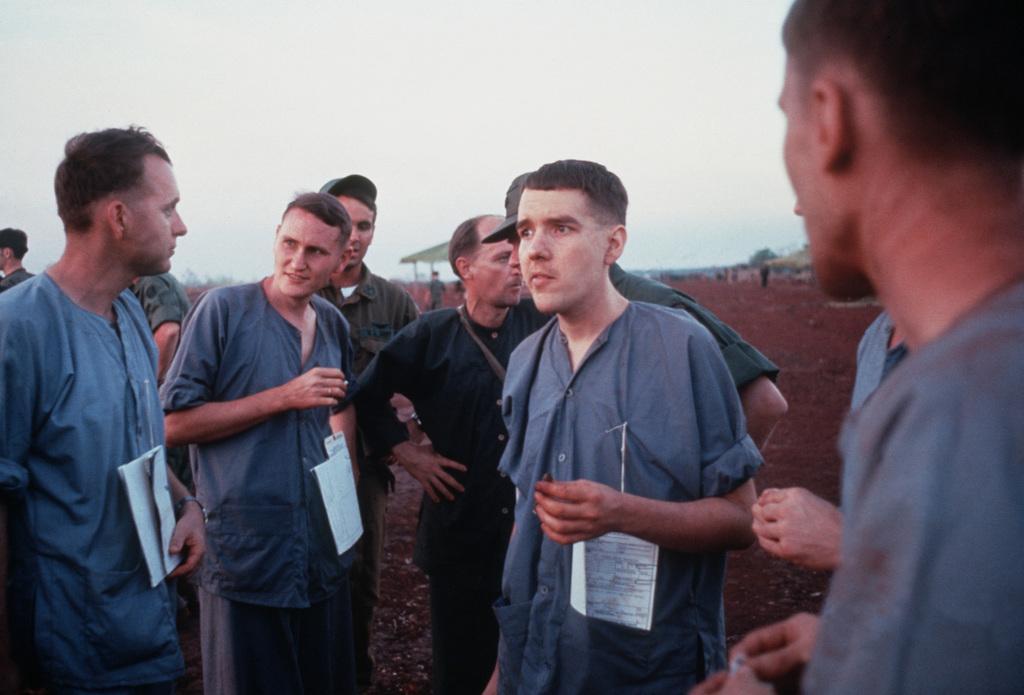Please provide a concise description of this image. In this picture we can see some people are standing, a man on the left side is holding a book, in the background we can see a tent, a tree and soil, there is the sky at the top of the picture. 